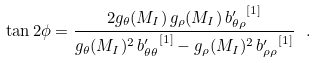<formula> <loc_0><loc_0><loc_500><loc_500>\tan 2 \phi = \frac { 2 g _ { \theta } ( M _ { I } ) \, g _ { \rho } ( M _ { I } ) \, { b ^ { \prime } _ { \theta \rho } } ^ { [ 1 ] } } { g _ { \theta } ( M _ { I } ) ^ { 2 } \, { b ^ { \prime } _ { \theta \theta } } ^ { [ 1 ] } - g _ { \rho } ( M _ { I } ) ^ { 2 } \, { b ^ { \prime } _ { \rho \rho } } ^ { [ 1 ] } } \ .</formula> 